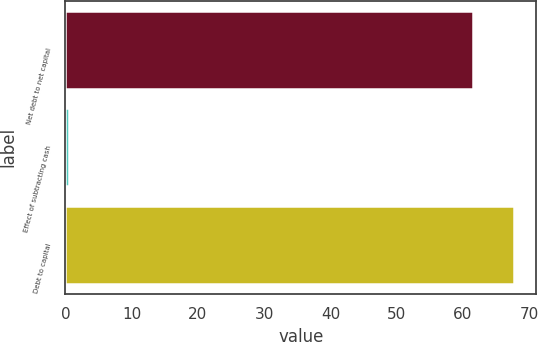<chart> <loc_0><loc_0><loc_500><loc_500><bar_chart><fcel>Net debt to net capital<fcel>Effect of subtracting cash<fcel>Debt to capital<nl><fcel>61.5<fcel>0.5<fcel>67.65<nl></chart> 